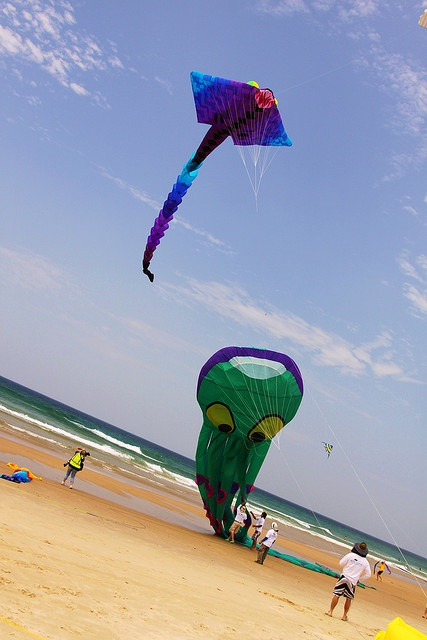Describe the objects in this image and their specific colors. I can see kite in darkgray, darkgreen, black, and olive tones, kite in darkgray, black, navy, purple, and darkblue tones, people in darkgray, lightgray, tan, and black tones, people in darkgray, black, yellow, gray, and olive tones, and people in darkgray, lavender, black, and maroon tones in this image. 